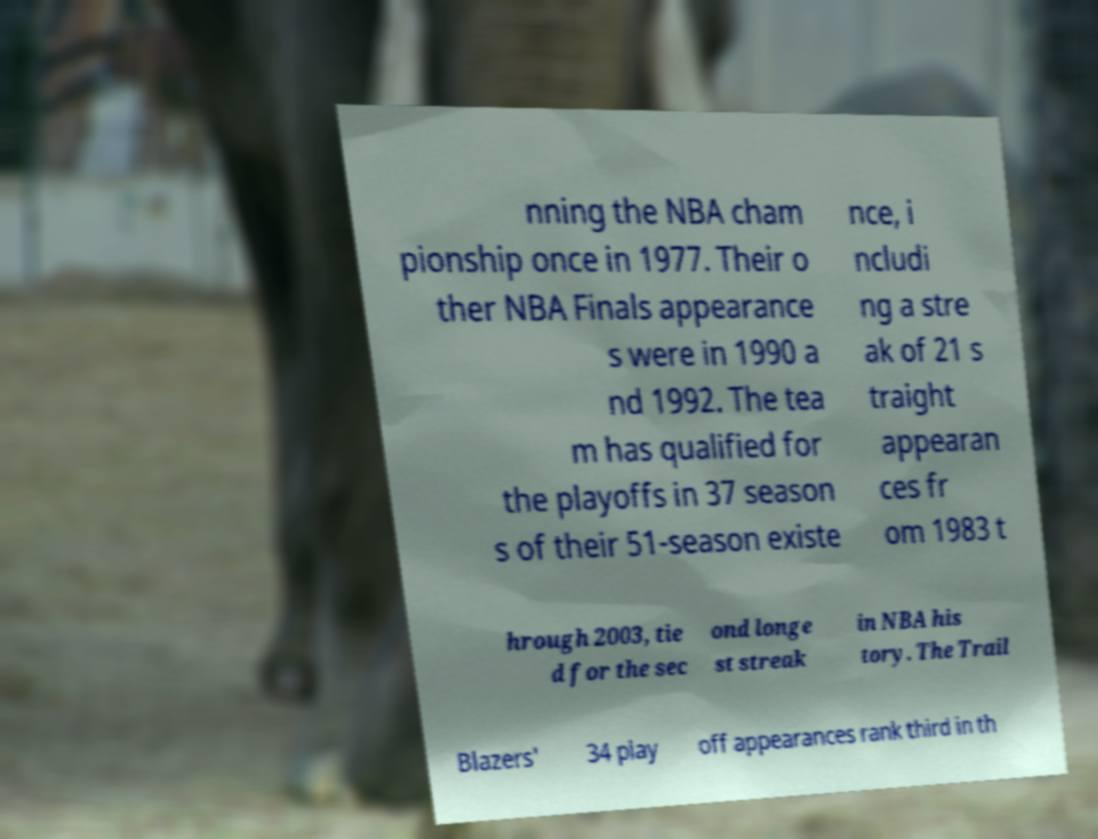Can you read and provide the text displayed in the image?This photo seems to have some interesting text. Can you extract and type it out for me? nning the NBA cham pionship once in 1977. Their o ther NBA Finals appearance s were in 1990 a nd 1992. The tea m has qualified for the playoffs in 37 season s of their 51-season existe nce, i ncludi ng a stre ak of 21 s traight appearan ces fr om 1983 t hrough 2003, tie d for the sec ond longe st streak in NBA his tory. The Trail Blazers' 34 play off appearances rank third in th 